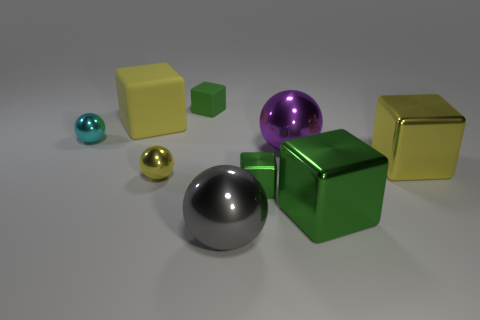There is a big object that is behind the cyan sphere; is it the same color as the small shiny sphere in front of the purple thing?
Ensure brevity in your answer.  Yes. There is a big yellow thing that is in front of the yellow block behind the tiny shiny object that is to the left of the big yellow rubber object; what shape is it?
Your answer should be compact. Cube. The small thing that is both behind the small yellow metal object and on the left side of the tiny green rubber cube has what shape?
Make the answer very short. Sphere. There is a small ball in front of the small sphere behind the big purple metallic object; how many metallic blocks are in front of it?
Ensure brevity in your answer.  2. What size is the purple metallic thing that is the same shape as the tiny yellow object?
Ensure brevity in your answer.  Large. Is there anything else that is the same size as the yellow metallic ball?
Keep it short and to the point. Yes. Is the material of the big yellow cube in front of the large yellow rubber block the same as the gray ball?
Give a very brief answer. Yes. What is the color of the other small object that is the same shape as the cyan thing?
Your response must be concise. Yellow. How many other objects are there of the same color as the tiny rubber object?
Your answer should be compact. 2. Does the tiny object that is right of the big gray ball have the same shape as the big object on the left side of the tiny rubber cube?
Your answer should be compact. Yes. 